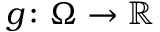<formula> <loc_0><loc_0><loc_500><loc_500>g \colon \Omega \to { \mathbb { R } }</formula> 